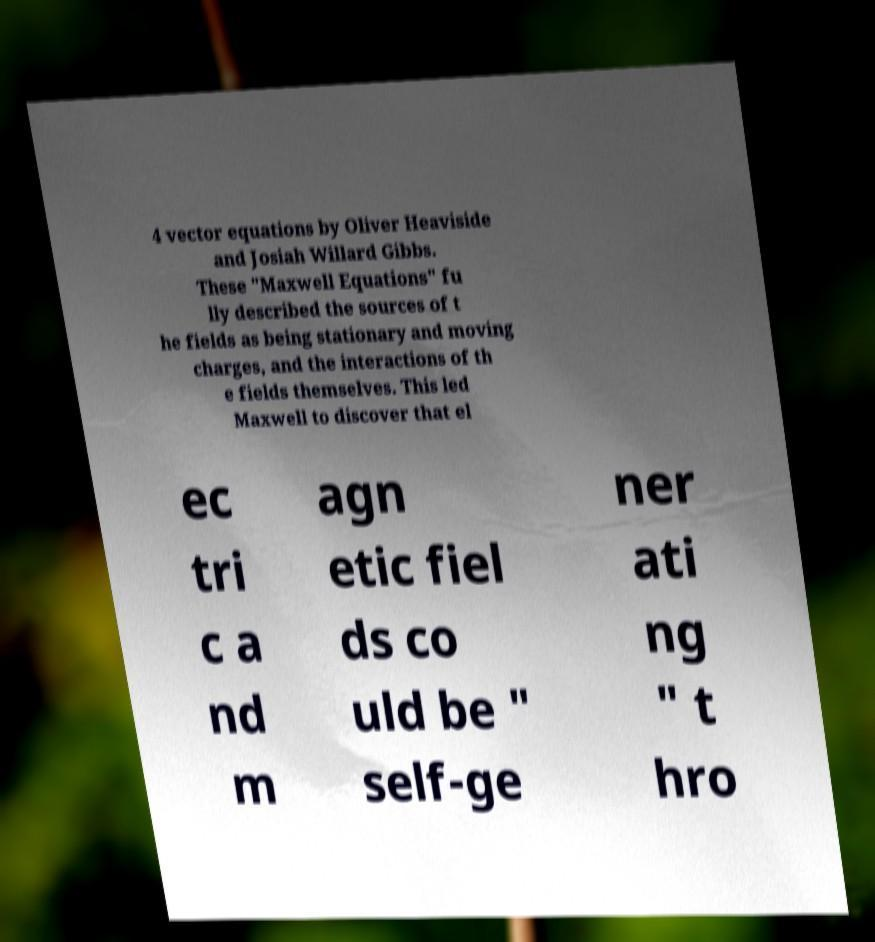Please read and relay the text visible in this image. What does it say? 4 vector equations by Oliver Heaviside and Josiah Willard Gibbs. These "Maxwell Equations" fu lly described the sources of t he fields as being stationary and moving charges, and the interactions of th e fields themselves. This led Maxwell to discover that el ec tri c a nd m agn etic fiel ds co uld be " self-ge ner ati ng " t hro 